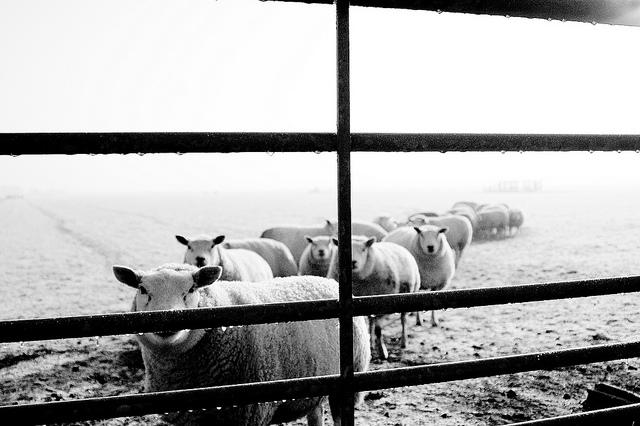Are these sheep?
Give a very brief answer. Yes. Can this animal fly?
Short answer required. No. What object is closest the camera?
Quick response, please. Fence. Do people count them to help sleep?
Be succinct. Yes. 